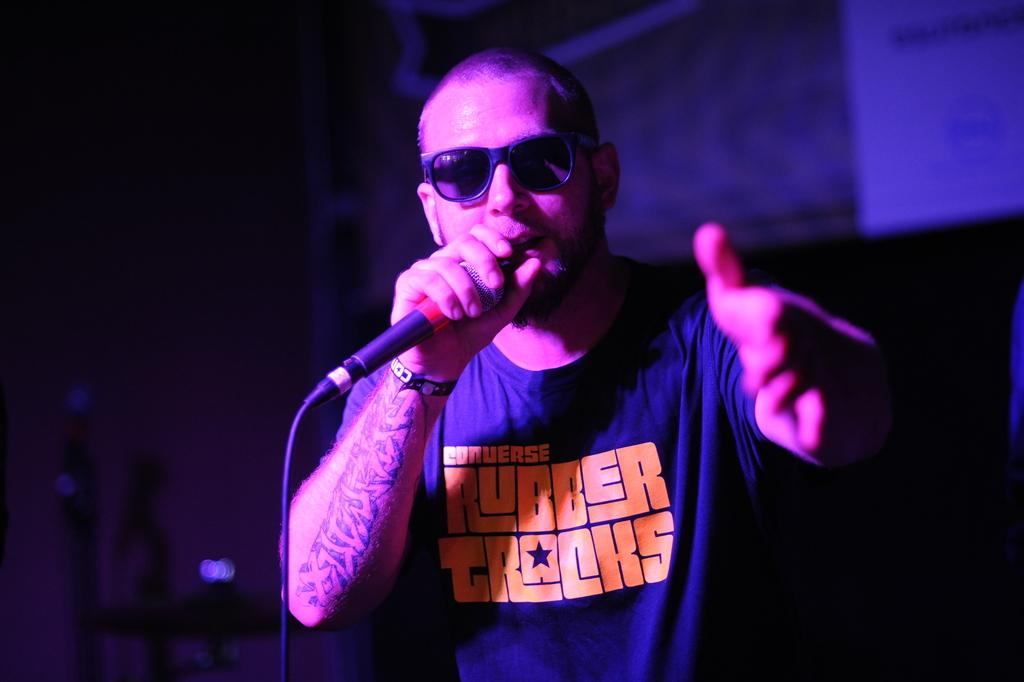What is the main subject of the image? The main subject of the image is a man. What is the man holding in his hand? The man is holding a mic in his hand. What is the man doing with the mic? The man is singing while holding the mic. Can you describe the background of the image? The background of the image is blurry. How many houses can be seen in the background of the image? There are no houses visible in the image; the background is blurry. What type of bird is perched on the man's shoulder in the image? There is no bird present in the image; the man is singing while holding a mic. 